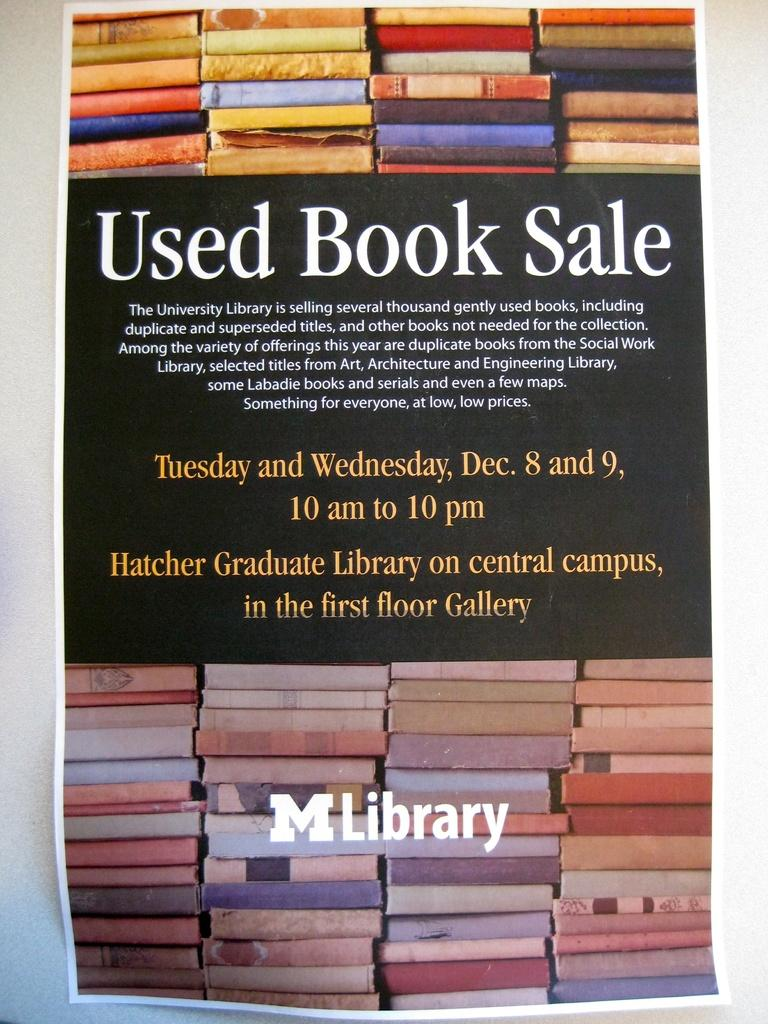<image>
Relay a brief, clear account of the picture shown. a poster for a Used Book Sale at the M Library 